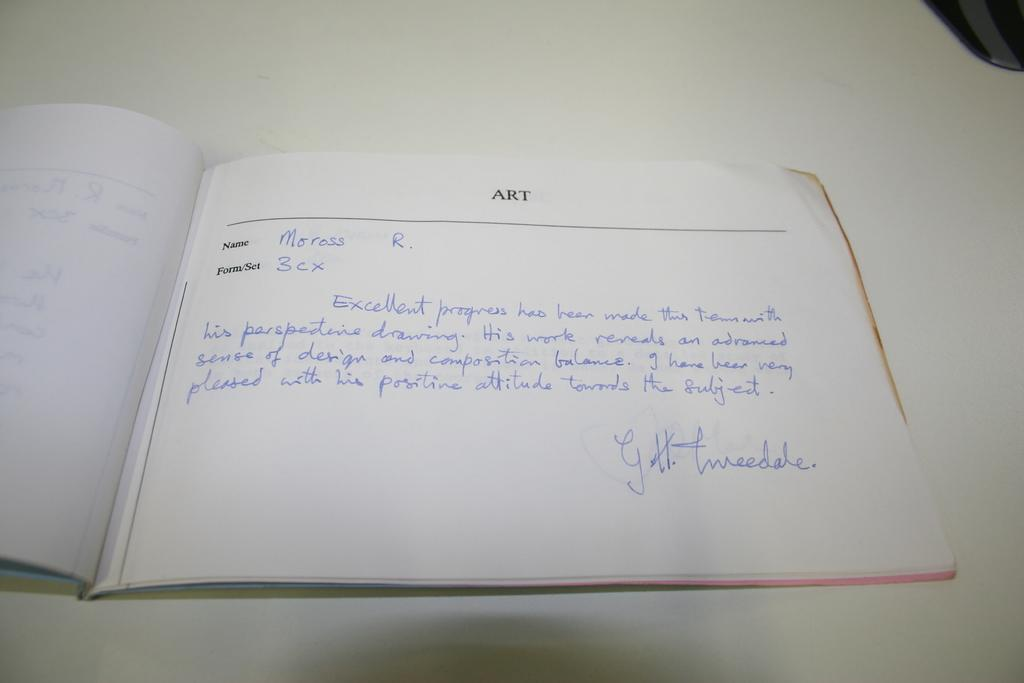<image>
Share a concise interpretation of the image provided. a guest book labeled ART is open on a table 